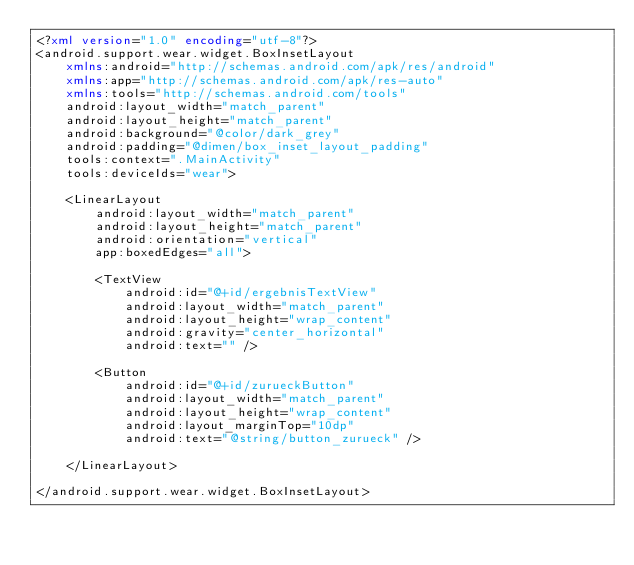Convert code to text. <code><loc_0><loc_0><loc_500><loc_500><_XML_><?xml version="1.0" encoding="utf-8"?>
<android.support.wear.widget.BoxInsetLayout
    xmlns:android="http://schemas.android.com/apk/res/android"
    xmlns:app="http://schemas.android.com/apk/res-auto"
    xmlns:tools="http://schemas.android.com/tools"
    android:layout_width="match_parent"
    android:layout_height="match_parent"
    android:background="@color/dark_grey"
    android:padding="@dimen/box_inset_layout_padding"
    tools:context=".MainActivity"
    tools:deviceIds="wear">

    <LinearLayout
        android:layout_width="match_parent"
        android:layout_height="match_parent"
        android:orientation="vertical"
        app:boxedEdges="all">

        <TextView
            android:id="@+id/ergebnisTextView"
            android:layout_width="match_parent"
            android:layout_height="wrap_content"
            android:gravity="center_horizontal"
            android:text="" />

        <Button
            android:id="@+id/zurueckButton"
            android:layout_width="match_parent"
            android:layout_height="wrap_content"
            android:layout_marginTop="10dp"
            android:text="@string/button_zurueck" />

    </LinearLayout>

</android.support.wear.widget.BoxInsetLayout></code> 